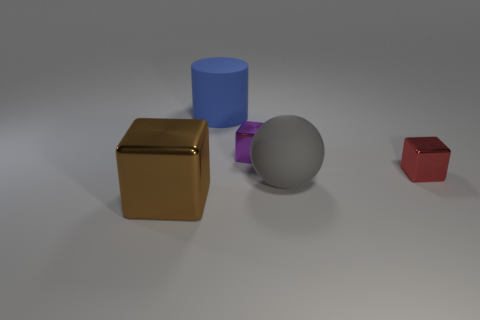Subtract all small purple metallic blocks. How many blocks are left? 2 Subtract 1 balls. How many balls are left? 0 Add 1 large green spheres. How many objects exist? 6 Subtract all red cubes. How many cubes are left? 2 Subtract all cubes. How many objects are left? 2 Subtract 1 brown cubes. How many objects are left? 4 Subtract all brown cylinders. Subtract all red balls. How many cylinders are left? 1 Subtract all green spheres. How many red cubes are left? 1 Subtract all large cylinders. Subtract all tiny yellow metal spheres. How many objects are left? 4 Add 1 blue objects. How many blue objects are left? 2 